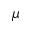<formula> <loc_0><loc_0><loc_500><loc_500>\mu</formula> 